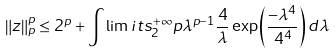<formula> <loc_0><loc_0><loc_500><loc_500>\left \| z \right \| _ { p } ^ { p } \leq 2 ^ { p } + \int \lim i t s _ { 2 } ^ { + \infty } p \lambda ^ { p - 1 } \frac { 4 } { \lambda } \exp \left ( \frac { - \lambda ^ { 4 } } { 4 ^ { 4 } } \right ) d \lambda</formula> 